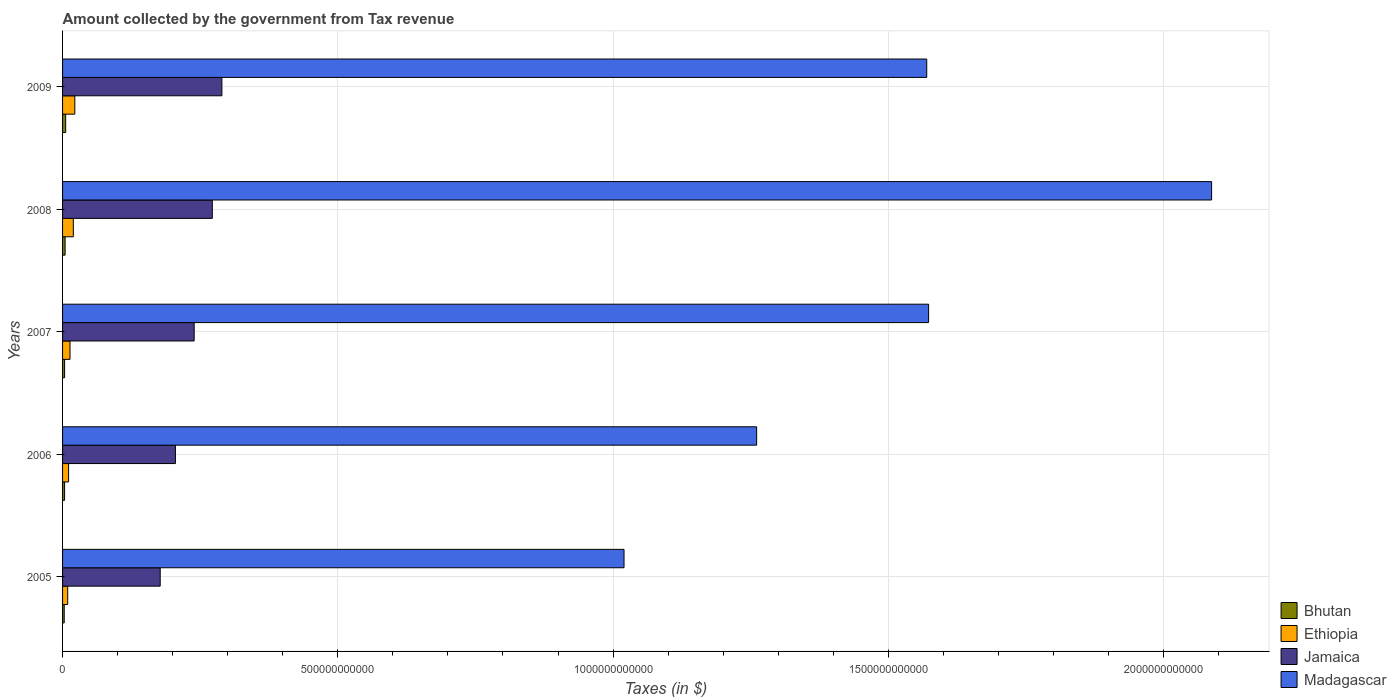How many groups of bars are there?
Your response must be concise. 5. Are the number of bars per tick equal to the number of legend labels?
Provide a succinct answer. Yes. How many bars are there on the 5th tick from the top?
Provide a succinct answer. 4. How many bars are there on the 5th tick from the bottom?
Your answer should be very brief. 4. What is the label of the 2nd group of bars from the top?
Your answer should be very brief. 2008. What is the amount collected by the government from tax revenue in Jamaica in 2006?
Provide a short and direct response. 2.05e+11. Across all years, what is the maximum amount collected by the government from tax revenue in Jamaica?
Keep it short and to the point. 2.89e+11. Across all years, what is the minimum amount collected by the government from tax revenue in Madagascar?
Keep it short and to the point. 1.02e+12. In which year was the amount collected by the government from tax revenue in Madagascar maximum?
Keep it short and to the point. 2008. In which year was the amount collected by the government from tax revenue in Jamaica minimum?
Your answer should be very brief. 2005. What is the total amount collected by the government from tax revenue in Bhutan in the graph?
Offer a very short reply. 2.07e+1. What is the difference between the amount collected by the government from tax revenue in Jamaica in 2005 and that in 2008?
Give a very brief answer. -9.46e+1. What is the difference between the amount collected by the government from tax revenue in Bhutan in 2006 and the amount collected by the government from tax revenue in Jamaica in 2007?
Your answer should be compact. -2.35e+11. What is the average amount collected by the government from tax revenue in Jamaica per year?
Give a very brief answer. 2.37e+11. In the year 2008, what is the difference between the amount collected by the government from tax revenue in Bhutan and amount collected by the government from tax revenue in Ethiopia?
Offer a terse response. -1.49e+1. In how many years, is the amount collected by the government from tax revenue in Bhutan greater than 1900000000000 $?
Provide a short and direct response. 0. What is the ratio of the amount collected by the government from tax revenue in Jamaica in 2007 to that in 2009?
Make the answer very short. 0.83. Is the difference between the amount collected by the government from tax revenue in Bhutan in 2005 and 2007 greater than the difference between the amount collected by the government from tax revenue in Ethiopia in 2005 and 2007?
Offer a very short reply. Yes. What is the difference between the highest and the second highest amount collected by the government from tax revenue in Madagascar?
Ensure brevity in your answer.  5.14e+11. What is the difference between the highest and the lowest amount collected by the government from tax revenue in Ethiopia?
Your response must be concise. 1.29e+1. In how many years, is the amount collected by the government from tax revenue in Jamaica greater than the average amount collected by the government from tax revenue in Jamaica taken over all years?
Offer a terse response. 3. What does the 1st bar from the top in 2008 represents?
Your answer should be very brief. Madagascar. What does the 2nd bar from the bottom in 2007 represents?
Your response must be concise. Ethiopia. Are all the bars in the graph horizontal?
Keep it short and to the point. Yes. What is the difference between two consecutive major ticks on the X-axis?
Your response must be concise. 5.00e+11. Does the graph contain grids?
Give a very brief answer. Yes. How many legend labels are there?
Keep it short and to the point. 4. How are the legend labels stacked?
Offer a very short reply. Vertical. What is the title of the graph?
Make the answer very short. Amount collected by the government from Tax revenue. What is the label or title of the X-axis?
Ensure brevity in your answer.  Taxes (in $). What is the Taxes (in $) in Bhutan in 2005?
Provide a short and direct response. 3.01e+09. What is the Taxes (in $) in Ethiopia in 2005?
Make the answer very short. 9.36e+09. What is the Taxes (in $) in Jamaica in 2005?
Keep it short and to the point. 1.77e+11. What is the Taxes (in $) in Madagascar in 2005?
Ensure brevity in your answer.  1.02e+12. What is the Taxes (in $) in Bhutan in 2006?
Provide a short and direct response. 3.67e+09. What is the Taxes (in $) in Ethiopia in 2006?
Give a very brief answer. 1.10e+1. What is the Taxes (in $) in Jamaica in 2006?
Provide a succinct answer. 2.05e+11. What is the Taxes (in $) of Madagascar in 2006?
Your answer should be very brief. 1.26e+12. What is the Taxes (in $) in Bhutan in 2007?
Offer a very short reply. 3.72e+09. What is the Taxes (in $) in Ethiopia in 2007?
Offer a terse response. 1.35e+1. What is the Taxes (in $) of Jamaica in 2007?
Keep it short and to the point. 2.39e+11. What is the Taxes (in $) of Madagascar in 2007?
Offer a terse response. 1.57e+12. What is the Taxes (in $) of Bhutan in 2008?
Keep it short and to the point. 4.61e+09. What is the Taxes (in $) in Ethiopia in 2008?
Offer a terse response. 1.96e+1. What is the Taxes (in $) in Jamaica in 2008?
Give a very brief answer. 2.72e+11. What is the Taxes (in $) in Madagascar in 2008?
Provide a succinct answer. 2.09e+12. What is the Taxes (in $) in Bhutan in 2009?
Your response must be concise. 5.65e+09. What is the Taxes (in $) in Ethiopia in 2009?
Your response must be concise. 2.22e+1. What is the Taxes (in $) of Jamaica in 2009?
Keep it short and to the point. 2.89e+11. What is the Taxes (in $) in Madagascar in 2009?
Give a very brief answer. 1.57e+12. Across all years, what is the maximum Taxes (in $) in Bhutan?
Your answer should be very brief. 5.65e+09. Across all years, what is the maximum Taxes (in $) of Ethiopia?
Your answer should be very brief. 2.22e+1. Across all years, what is the maximum Taxes (in $) in Jamaica?
Your answer should be compact. 2.89e+11. Across all years, what is the maximum Taxes (in $) in Madagascar?
Provide a short and direct response. 2.09e+12. Across all years, what is the minimum Taxes (in $) in Bhutan?
Your response must be concise. 3.01e+09. Across all years, what is the minimum Taxes (in $) in Ethiopia?
Your response must be concise. 9.36e+09. Across all years, what is the minimum Taxes (in $) of Jamaica?
Offer a terse response. 1.77e+11. Across all years, what is the minimum Taxes (in $) of Madagascar?
Make the answer very short. 1.02e+12. What is the total Taxes (in $) in Bhutan in the graph?
Your answer should be very brief. 2.07e+1. What is the total Taxes (in $) in Ethiopia in the graph?
Keep it short and to the point. 7.57e+1. What is the total Taxes (in $) in Jamaica in the graph?
Your answer should be very brief. 1.18e+12. What is the total Taxes (in $) of Madagascar in the graph?
Your answer should be very brief. 7.51e+12. What is the difference between the Taxes (in $) of Bhutan in 2005 and that in 2006?
Your answer should be compact. -6.59e+08. What is the difference between the Taxes (in $) of Ethiopia in 2005 and that in 2006?
Your answer should be very brief. -1.60e+09. What is the difference between the Taxes (in $) of Jamaica in 2005 and that in 2006?
Keep it short and to the point. -2.76e+1. What is the difference between the Taxes (in $) of Madagascar in 2005 and that in 2006?
Your answer should be compact. -2.41e+11. What is the difference between the Taxes (in $) in Bhutan in 2005 and that in 2007?
Keep it short and to the point. -7.05e+08. What is the difference between the Taxes (in $) of Ethiopia in 2005 and that in 2007?
Provide a short and direct response. -4.18e+09. What is the difference between the Taxes (in $) of Jamaica in 2005 and that in 2007?
Offer a terse response. -6.17e+1. What is the difference between the Taxes (in $) of Madagascar in 2005 and that in 2007?
Your answer should be compact. -5.53e+11. What is the difference between the Taxes (in $) in Bhutan in 2005 and that in 2008?
Your answer should be very brief. -1.59e+09. What is the difference between the Taxes (in $) of Ethiopia in 2005 and that in 2008?
Keep it short and to the point. -1.02e+1. What is the difference between the Taxes (in $) in Jamaica in 2005 and that in 2008?
Your response must be concise. -9.46e+1. What is the difference between the Taxes (in $) of Madagascar in 2005 and that in 2008?
Give a very brief answer. -1.07e+12. What is the difference between the Taxes (in $) in Bhutan in 2005 and that in 2009?
Offer a very short reply. -2.64e+09. What is the difference between the Taxes (in $) of Ethiopia in 2005 and that in 2009?
Offer a terse response. -1.29e+1. What is the difference between the Taxes (in $) in Jamaica in 2005 and that in 2009?
Give a very brief answer. -1.12e+11. What is the difference between the Taxes (in $) in Madagascar in 2005 and that in 2009?
Ensure brevity in your answer.  -5.50e+11. What is the difference between the Taxes (in $) in Bhutan in 2006 and that in 2007?
Your response must be concise. -4.57e+07. What is the difference between the Taxes (in $) in Ethiopia in 2006 and that in 2007?
Ensure brevity in your answer.  -2.58e+09. What is the difference between the Taxes (in $) in Jamaica in 2006 and that in 2007?
Provide a succinct answer. -3.41e+1. What is the difference between the Taxes (in $) in Madagascar in 2006 and that in 2007?
Ensure brevity in your answer.  -3.12e+11. What is the difference between the Taxes (in $) in Bhutan in 2006 and that in 2008?
Your answer should be compact. -9.34e+08. What is the difference between the Taxes (in $) of Ethiopia in 2006 and that in 2008?
Provide a short and direct response. -8.59e+09. What is the difference between the Taxes (in $) of Jamaica in 2006 and that in 2008?
Give a very brief answer. -6.70e+1. What is the difference between the Taxes (in $) of Madagascar in 2006 and that in 2008?
Provide a short and direct response. -8.26e+11. What is the difference between the Taxes (in $) of Bhutan in 2006 and that in 2009?
Provide a short and direct response. -1.98e+09. What is the difference between the Taxes (in $) of Ethiopia in 2006 and that in 2009?
Offer a terse response. -1.13e+1. What is the difference between the Taxes (in $) in Jamaica in 2006 and that in 2009?
Provide a short and direct response. -8.44e+1. What is the difference between the Taxes (in $) in Madagascar in 2006 and that in 2009?
Keep it short and to the point. -3.09e+11. What is the difference between the Taxes (in $) of Bhutan in 2007 and that in 2008?
Offer a terse response. -8.88e+08. What is the difference between the Taxes (in $) in Ethiopia in 2007 and that in 2008?
Your answer should be very brief. -6.01e+09. What is the difference between the Taxes (in $) of Jamaica in 2007 and that in 2008?
Ensure brevity in your answer.  -3.29e+1. What is the difference between the Taxes (in $) in Madagascar in 2007 and that in 2008?
Your answer should be compact. -5.14e+11. What is the difference between the Taxes (in $) of Bhutan in 2007 and that in 2009?
Your answer should be compact. -1.94e+09. What is the difference between the Taxes (in $) of Ethiopia in 2007 and that in 2009?
Ensure brevity in your answer.  -8.70e+09. What is the difference between the Taxes (in $) of Jamaica in 2007 and that in 2009?
Give a very brief answer. -5.03e+1. What is the difference between the Taxes (in $) of Madagascar in 2007 and that in 2009?
Give a very brief answer. 3.39e+09. What is the difference between the Taxes (in $) of Bhutan in 2008 and that in 2009?
Offer a very short reply. -1.05e+09. What is the difference between the Taxes (in $) of Ethiopia in 2008 and that in 2009?
Give a very brief answer. -2.69e+09. What is the difference between the Taxes (in $) of Jamaica in 2008 and that in 2009?
Give a very brief answer. -1.74e+1. What is the difference between the Taxes (in $) of Madagascar in 2008 and that in 2009?
Offer a terse response. 5.17e+11. What is the difference between the Taxes (in $) of Bhutan in 2005 and the Taxes (in $) of Ethiopia in 2006?
Your response must be concise. -7.95e+09. What is the difference between the Taxes (in $) of Bhutan in 2005 and the Taxes (in $) of Jamaica in 2006?
Offer a terse response. -2.02e+11. What is the difference between the Taxes (in $) in Bhutan in 2005 and the Taxes (in $) in Madagascar in 2006?
Offer a terse response. -1.26e+12. What is the difference between the Taxes (in $) of Ethiopia in 2005 and the Taxes (in $) of Jamaica in 2006?
Make the answer very short. -1.96e+11. What is the difference between the Taxes (in $) of Ethiopia in 2005 and the Taxes (in $) of Madagascar in 2006?
Your answer should be very brief. -1.25e+12. What is the difference between the Taxes (in $) in Jamaica in 2005 and the Taxes (in $) in Madagascar in 2006?
Provide a short and direct response. -1.08e+12. What is the difference between the Taxes (in $) in Bhutan in 2005 and the Taxes (in $) in Ethiopia in 2007?
Provide a short and direct response. -1.05e+1. What is the difference between the Taxes (in $) of Bhutan in 2005 and the Taxes (in $) of Jamaica in 2007?
Give a very brief answer. -2.36e+11. What is the difference between the Taxes (in $) in Bhutan in 2005 and the Taxes (in $) in Madagascar in 2007?
Keep it short and to the point. -1.57e+12. What is the difference between the Taxes (in $) in Ethiopia in 2005 and the Taxes (in $) in Jamaica in 2007?
Provide a succinct answer. -2.30e+11. What is the difference between the Taxes (in $) of Ethiopia in 2005 and the Taxes (in $) of Madagascar in 2007?
Offer a terse response. -1.56e+12. What is the difference between the Taxes (in $) of Jamaica in 2005 and the Taxes (in $) of Madagascar in 2007?
Keep it short and to the point. -1.40e+12. What is the difference between the Taxes (in $) in Bhutan in 2005 and the Taxes (in $) in Ethiopia in 2008?
Provide a short and direct response. -1.65e+1. What is the difference between the Taxes (in $) of Bhutan in 2005 and the Taxes (in $) of Jamaica in 2008?
Ensure brevity in your answer.  -2.69e+11. What is the difference between the Taxes (in $) in Bhutan in 2005 and the Taxes (in $) in Madagascar in 2008?
Keep it short and to the point. -2.08e+12. What is the difference between the Taxes (in $) in Ethiopia in 2005 and the Taxes (in $) in Jamaica in 2008?
Provide a succinct answer. -2.63e+11. What is the difference between the Taxes (in $) in Ethiopia in 2005 and the Taxes (in $) in Madagascar in 2008?
Your response must be concise. -2.08e+12. What is the difference between the Taxes (in $) of Jamaica in 2005 and the Taxes (in $) of Madagascar in 2008?
Keep it short and to the point. -1.91e+12. What is the difference between the Taxes (in $) of Bhutan in 2005 and the Taxes (in $) of Ethiopia in 2009?
Make the answer very short. -1.92e+1. What is the difference between the Taxes (in $) in Bhutan in 2005 and the Taxes (in $) in Jamaica in 2009?
Your response must be concise. -2.86e+11. What is the difference between the Taxes (in $) in Bhutan in 2005 and the Taxes (in $) in Madagascar in 2009?
Your answer should be compact. -1.57e+12. What is the difference between the Taxes (in $) in Ethiopia in 2005 and the Taxes (in $) in Jamaica in 2009?
Keep it short and to the point. -2.80e+11. What is the difference between the Taxes (in $) in Ethiopia in 2005 and the Taxes (in $) in Madagascar in 2009?
Your response must be concise. -1.56e+12. What is the difference between the Taxes (in $) of Jamaica in 2005 and the Taxes (in $) of Madagascar in 2009?
Your answer should be very brief. -1.39e+12. What is the difference between the Taxes (in $) in Bhutan in 2006 and the Taxes (in $) in Ethiopia in 2007?
Your response must be concise. -9.87e+09. What is the difference between the Taxes (in $) of Bhutan in 2006 and the Taxes (in $) of Jamaica in 2007?
Your answer should be compact. -2.35e+11. What is the difference between the Taxes (in $) in Bhutan in 2006 and the Taxes (in $) in Madagascar in 2007?
Provide a short and direct response. -1.57e+12. What is the difference between the Taxes (in $) in Ethiopia in 2006 and the Taxes (in $) in Jamaica in 2007?
Your answer should be compact. -2.28e+11. What is the difference between the Taxes (in $) in Ethiopia in 2006 and the Taxes (in $) in Madagascar in 2007?
Your answer should be compact. -1.56e+12. What is the difference between the Taxes (in $) in Jamaica in 2006 and the Taxes (in $) in Madagascar in 2007?
Provide a short and direct response. -1.37e+12. What is the difference between the Taxes (in $) of Bhutan in 2006 and the Taxes (in $) of Ethiopia in 2008?
Make the answer very short. -1.59e+1. What is the difference between the Taxes (in $) in Bhutan in 2006 and the Taxes (in $) in Jamaica in 2008?
Provide a succinct answer. -2.68e+11. What is the difference between the Taxes (in $) in Bhutan in 2006 and the Taxes (in $) in Madagascar in 2008?
Make the answer very short. -2.08e+12. What is the difference between the Taxes (in $) of Ethiopia in 2006 and the Taxes (in $) of Jamaica in 2008?
Your answer should be very brief. -2.61e+11. What is the difference between the Taxes (in $) of Ethiopia in 2006 and the Taxes (in $) of Madagascar in 2008?
Keep it short and to the point. -2.08e+12. What is the difference between the Taxes (in $) of Jamaica in 2006 and the Taxes (in $) of Madagascar in 2008?
Give a very brief answer. -1.88e+12. What is the difference between the Taxes (in $) of Bhutan in 2006 and the Taxes (in $) of Ethiopia in 2009?
Provide a succinct answer. -1.86e+1. What is the difference between the Taxes (in $) in Bhutan in 2006 and the Taxes (in $) in Jamaica in 2009?
Your answer should be very brief. -2.86e+11. What is the difference between the Taxes (in $) in Bhutan in 2006 and the Taxes (in $) in Madagascar in 2009?
Offer a terse response. -1.57e+12. What is the difference between the Taxes (in $) of Ethiopia in 2006 and the Taxes (in $) of Jamaica in 2009?
Give a very brief answer. -2.78e+11. What is the difference between the Taxes (in $) in Ethiopia in 2006 and the Taxes (in $) in Madagascar in 2009?
Ensure brevity in your answer.  -1.56e+12. What is the difference between the Taxes (in $) of Jamaica in 2006 and the Taxes (in $) of Madagascar in 2009?
Your response must be concise. -1.36e+12. What is the difference between the Taxes (in $) in Bhutan in 2007 and the Taxes (in $) in Ethiopia in 2008?
Your response must be concise. -1.58e+1. What is the difference between the Taxes (in $) in Bhutan in 2007 and the Taxes (in $) in Jamaica in 2008?
Give a very brief answer. -2.68e+11. What is the difference between the Taxes (in $) of Bhutan in 2007 and the Taxes (in $) of Madagascar in 2008?
Your answer should be compact. -2.08e+12. What is the difference between the Taxes (in $) in Ethiopia in 2007 and the Taxes (in $) in Jamaica in 2008?
Offer a very short reply. -2.58e+11. What is the difference between the Taxes (in $) of Ethiopia in 2007 and the Taxes (in $) of Madagascar in 2008?
Your answer should be compact. -2.07e+12. What is the difference between the Taxes (in $) of Jamaica in 2007 and the Taxes (in $) of Madagascar in 2008?
Offer a very short reply. -1.85e+12. What is the difference between the Taxes (in $) in Bhutan in 2007 and the Taxes (in $) in Ethiopia in 2009?
Give a very brief answer. -1.85e+1. What is the difference between the Taxes (in $) in Bhutan in 2007 and the Taxes (in $) in Jamaica in 2009?
Provide a short and direct response. -2.86e+11. What is the difference between the Taxes (in $) in Bhutan in 2007 and the Taxes (in $) in Madagascar in 2009?
Your answer should be very brief. -1.57e+12. What is the difference between the Taxes (in $) of Ethiopia in 2007 and the Taxes (in $) of Jamaica in 2009?
Offer a very short reply. -2.76e+11. What is the difference between the Taxes (in $) of Ethiopia in 2007 and the Taxes (in $) of Madagascar in 2009?
Your answer should be very brief. -1.56e+12. What is the difference between the Taxes (in $) in Jamaica in 2007 and the Taxes (in $) in Madagascar in 2009?
Give a very brief answer. -1.33e+12. What is the difference between the Taxes (in $) in Bhutan in 2008 and the Taxes (in $) in Ethiopia in 2009?
Provide a short and direct response. -1.76e+1. What is the difference between the Taxes (in $) of Bhutan in 2008 and the Taxes (in $) of Jamaica in 2009?
Ensure brevity in your answer.  -2.85e+11. What is the difference between the Taxes (in $) of Bhutan in 2008 and the Taxes (in $) of Madagascar in 2009?
Provide a short and direct response. -1.57e+12. What is the difference between the Taxes (in $) of Ethiopia in 2008 and the Taxes (in $) of Jamaica in 2009?
Your response must be concise. -2.70e+11. What is the difference between the Taxes (in $) of Ethiopia in 2008 and the Taxes (in $) of Madagascar in 2009?
Offer a terse response. -1.55e+12. What is the difference between the Taxes (in $) in Jamaica in 2008 and the Taxes (in $) in Madagascar in 2009?
Provide a succinct answer. -1.30e+12. What is the average Taxes (in $) of Bhutan per year?
Your response must be concise. 4.13e+09. What is the average Taxes (in $) in Ethiopia per year?
Provide a succinct answer. 1.51e+1. What is the average Taxes (in $) of Jamaica per year?
Provide a succinct answer. 2.37e+11. What is the average Taxes (in $) in Madagascar per year?
Your answer should be very brief. 1.50e+12. In the year 2005, what is the difference between the Taxes (in $) of Bhutan and Taxes (in $) of Ethiopia?
Give a very brief answer. -6.35e+09. In the year 2005, what is the difference between the Taxes (in $) of Bhutan and Taxes (in $) of Jamaica?
Provide a succinct answer. -1.74e+11. In the year 2005, what is the difference between the Taxes (in $) in Bhutan and Taxes (in $) in Madagascar?
Ensure brevity in your answer.  -1.02e+12. In the year 2005, what is the difference between the Taxes (in $) in Ethiopia and Taxes (in $) in Jamaica?
Your answer should be compact. -1.68e+11. In the year 2005, what is the difference between the Taxes (in $) in Ethiopia and Taxes (in $) in Madagascar?
Your response must be concise. -1.01e+12. In the year 2005, what is the difference between the Taxes (in $) in Jamaica and Taxes (in $) in Madagascar?
Provide a succinct answer. -8.43e+11. In the year 2006, what is the difference between the Taxes (in $) in Bhutan and Taxes (in $) in Ethiopia?
Keep it short and to the point. -7.29e+09. In the year 2006, what is the difference between the Taxes (in $) of Bhutan and Taxes (in $) of Jamaica?
Your answer should be very brief. -2.01e+11. In the year 2006, what is the difference between the Taxes (in $) of Bhutan and Taxes (in $) of Madagascar?
Provide a short and direct response. -1.26e+12. In the year 2006, what is the difference between the Taxes (in $) in Ethiopia and Taxes (in $) in Jamaica?
Your answer should be compact. -1.94e+11. In the year 2006, what is the difference between the Taxes (in $) of Ethiopia and Taxes (in $) of Madagascar?
Provide a succinct answer. -1.25e+12. In the year 2006, what is the difference between the Taxes (in $) in Jamaica and Taxes (in $) in Madagascar?
Your response must be concise. -1.06e+12. In the year 2007, what is the difference between the Taxes (in $) in Bhutan and Taxes (in $) in Ethiopia?
Your answer should be very brief. -9.82e+09. In the year 2007, what is the difference between the Taxes (in $) of Bhutan and Taxes (in $) of Jamaica?
Your answer should be compact. -2.35e+11. In the year 2007, what is the difference between the Taxes (in $) of Bhutan and Taxes (in $) of Madagascar?
Your response must be concise. -1.57e+12. In the year 2007, what is the difference between the Taxes (in $) of Ethiopia and Taxes (in $) of Jamaica?
Give a very brief answer. -2.26e+11. In the year 2007, what is the difference between the Taxes (in $) of Ethiopia and Taxes (in $) of Madagascar?
Provide a short and direct response. -1.56e+12. In the year 2007, what is the difference between the Taxes (in $) in Jamaica and Taxes (in $) in Madagascar?
Ensure brevity in your answer.  -1.33e+12. In the year 2008, what is the difference between the Taxes (in $) of Bhutan and Taxes (in $) of Ethiopia?
Your response must be concise. -1.49e+1. In the year 2008, what is the difference between the Taxes (in $) of Bhutan and Taxes (in $) of Jamaica?
Your response must be concise. -2.67e+11. In the year 2008, what is the difference between the Taxes (in $) in Bhutan and Taxes (in $) in Madagascar?
Give a very brief answer. -2.08e+12. In the year 2008, what is the difference between the Taxes (in $) in Ethiopia and Taxes (in $) in Jamaica?
Your response must be concise. -2.52e+11. In the year 2008, what is the difference between the Taxes (in $) in Ethiopia and Taxes (in $) in Madagascar?
Offer a terse response. -2.07e+12. In the year 2008, what is the difference between the Taxes (in $) in Jamaica and Taxes (in $) in Madagascar?
Make the answer very short. -1.82e+12. In the year 2009, what is the difference between the Taxes (in $) of Bhutan and Taxes (in $) of Ethiopia?
Ensure brevity in your answer.  -1.66e+1. In the year 2009, what is the difference between the Taxes (in $) in Bhutan and Taxes (in $) in Jamaica?
Your answer should be compact. -2.84e+11. In the year 2009, what is the difference between the Taxes (in $) of Bhutan and Taxes (in $) of Madagascar?
Ensure brevity in your answer.  -1.56e+12. In the year 2009, what is the difference between the Taxes (in $) of Ethiopia and Taxes (in $) of Jamaica?
Give a very brief answer. -2.67e+11. In the year 2009, what is the difference between the Taxes (in $) in Ethiopia and Taxes (in $) in Madagascar?
Your response must be concise. -1.55e+12. In the year 2009, what is the difference between the Taxes (in $) of Jamaica and Taxes (in $) of Madagascar?
Ensure brevity in your answer.  -1.28e+12. What is the ratio of the Taxes (in $) in Bhutan in 2005 to that in 2006?
Your response must be concise. 0.82. What is the ratio of the Taxes (in $) in Ethiopia in 2005 to that in 2006?
Your answer should be very brief. 0.85. What is the ratio of the Taxes (in $) of Jamaica in 2005 to that in 2006?
Keep it short and to the point. 0.87. What is the ratio of the Taxes (in $) in Madagascar in 2005 to that in 2006?
Your answer should be very brief. 0.81. What is the ratio of the Taxes (in $) of Bhutan in 2005 to that in 2007?
Provide a succinct answer. 0.81. What is the ratio of the Taxes (in $) of Ethiopia in 2005 to that in 2007?
Offer a terse response. 0.69. What is the ratio of the Taxes (in $) in Jamaica in 2005 to that in 2007?
Keep it short and to the point. 0.74. What is the ratio of the Taxes (in $) in Madagascar in 2005 to that in 2007?
Provide a succinct answer. 0.65. What is the ratio of the Taxes (in $) of Bhutan in 2005 to that in 2008?
Ensure brevity in your answer.  0.65. What is the ratio of the Taxes (in $) in Ethiopia in 2005 to that in 2008?
Provide a short and direct response. 0.48. What is the ratio of the Taxes (in $) of Jamaica in 2005 to that in 2008?
Your answer should be very brief. 0.65. What is the ratio of the Taxes (in $) of Madagascar in 2005 to that in 2008?
Your answer should be compact. 0.49. What is the ratio of the Taxes (in $) in Bhutan in 2005 to that in 2009?
Give a very brief answer. 0.53. What is the ratio of the Taxes (in $) in Ethiopia in 2005 to that in 2009?
Ensure brevity in your answer.  0.42. What is the ratio of the Taxes (in $) in Jamaica in 2005 to that in 2009?
Provide a short and direct response. 0.61. What is the ratio of the Taxes (in $) of Madagascar in 2005 to that in 2009?
Ensure brevity in your answer.  0.65. What is the ratio of the Taxes (in $) in Ethiopia in 2006 to that in 2007?
Your answer should be compact. 0.81. What is the ratio of the Taxes (in $) of Jamaica in 2006 to that in 2007?
Provide a short and direct response. 0.86. What is the ratio of the Taxes (in $) of Madagascar in 2006 to that in 2007?
Your response must be concise. 0.8. What is the ratio of the Taxes (in $) in Bhutan in 2006 to that in 2008?
Your answer should be very brief. 0.8. What is the ratio of the Taxes (in $) of Ethiopia in 2006 to that in 2008?
Provide a succinct answer. 0.56. What is the ratio of the Taxes (in $) of Jamaica in 2006 to that in 2008?
Your answer should be very brief. 0.75. What is the ratio of the Taxes (in $) of Madagascar in 2006 to that in 2008?
Your answer should be very brief. 0.6. What is the ratio of the Taxes (in $) in Bhutan in 2006 to that in 2009?
Provide a succinct answer. 0.65. What is the ratio of the Taxes (in $) of Ethiopia in 2006 to that in 2009?
Offer a terse response. 0.49. What is the ratio of the Taxes (in $) of Jamaica in 2006 to that in 2009?
Your answer should be compact. 0.71. What is the ratio of the Taxes (in $) of Madagascar in 2006 to that in 2009?
Your answer should be compact. 0.8. What is the ratio of the Taxes (in $) in Bhutan in 2007 to that in 2008?
Provide a succinct answer. 0.81. What is the ratio of the Taxes (in $) in Ethiopia in 2007 to that in 2008?
Offer a very short reply. 0.69. What is the ratio of the Taxes (in $) of Jamaica in 2007 to that in 2008?
Provide a succinct answer. 0.88. What is the ratio of the Taxes (in $) of Madagascar in 2007 to that in 2008?
Your answer should be very brief. 0.75. What is the ratio of the Taxes (in $) of Bhutan in 2007 to that in 2009?
Provide a short and direct response. 0.66. What is the ratio of the Taxes (in $) of Ethiopia in 2007 to that in 2009?
Offer a terse response. 0.61. What is the ratio of the Taxes (in $) in Jamaica in 2007 to that in 2009?
Provide a succinct answer. 0.83. What is the ratio of the Taxes (in $) of Bhutan in 2008 to that in 2009?
Provide a succinct answer. 0.81. What is the ratio of the Taxes (in $) of Ethiopia in 2008 to that in 2009?
Ensure brevity in your answer.  0.88. What is the ratio of the Taxes (in $) in Jamaica in 2008 to that in 2009?
Make the answer very short. 0.94. What is the ratio of the Taxes (in $) in Madagascar in 2008 to that in 2009?
Offer a very short reply. 1.33. What is the difference between the highest and the second highest Taxes (in $) of Bhutan?
Provide a succinct answer. 1.05e+09. What is the difference between the highest and the second highest Taxes (in $) in Ethiopia?
Make the answer very short. 2.69e+09. What is the difference between the highest and the second highest Taxes (in $) in Jamaica?
Provide a short and direct response. 1.74e+1. What is the difference between the highest and the second highest Taxes (in $) in Madagascar?
Make the answer very short. 5.14e+11. What is the difference between the highest and the lowest Taxes (in $) of Bhutan?
Offer a very short reply. 2.64e+09. What is the difference between the highest and the lowest Taxes (in $) of Ethiopia?
Ensure brevity in your answer.  1.29e+1. What is the difference between the highest and the lowest Taxes (in $) in Jamaica?
Your answer should be compact. 1.12e+11. What is the difference between the highest and the lowest Taxes (in $) in Madagascar?
Provide a short and direct response. 1.07e+12. 